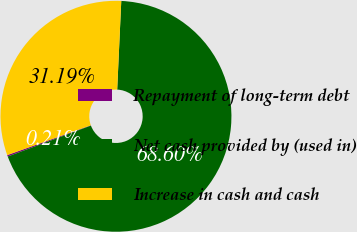Convert chart. <chart><loc_0><loc_0><loc_500><loc_500><pie_chart><fcel>Repayment of long-term debt<fcel>Net cash provided by (used in)<fcel>Increase in cash and cash<nl><fcel>0.21%<fcel>68.6%<fcel>31.19%<nl></chart> 